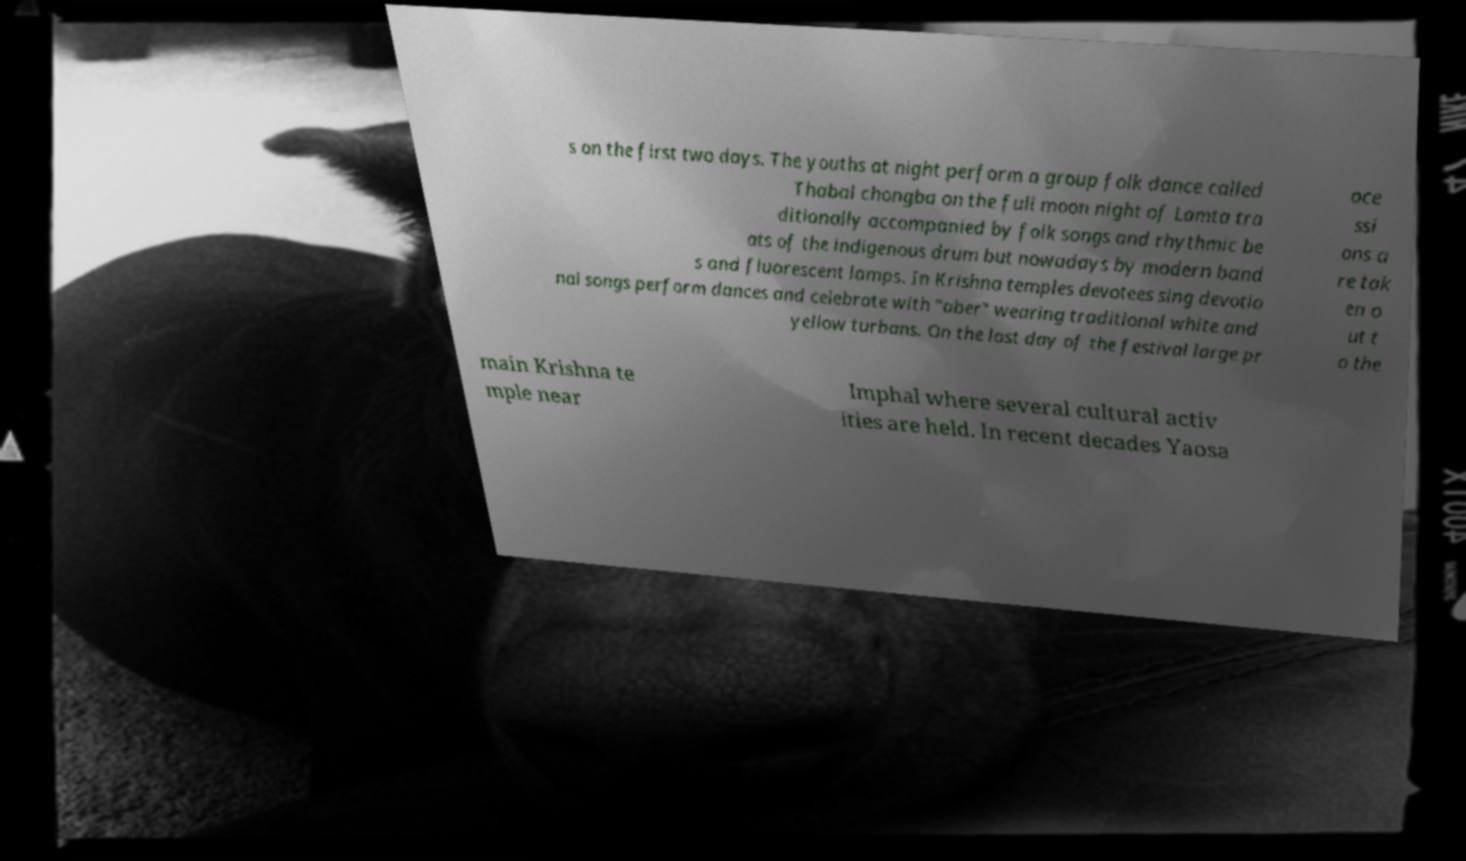Please identify and transcribe the text found in this image. s on the first two days. The youths at night perform a group folk dance called Thabal chongba on the full moon night of Lamta tra ditionally accompanied by folk songs and rhythmic be ats of the indigenous drum but nowadays by modern band s and fluorescent lamps. In Krishna temples devotees sing devotio nal songs perform dances and celebrate with "aber" wearing traditional white and yellow turbans. On the last day of the festival large pr oce ssi ons a re tak en o ut t o the main Krishna te mple near Imphal where several cultural activ ities are held. In recent decades Yaosa 